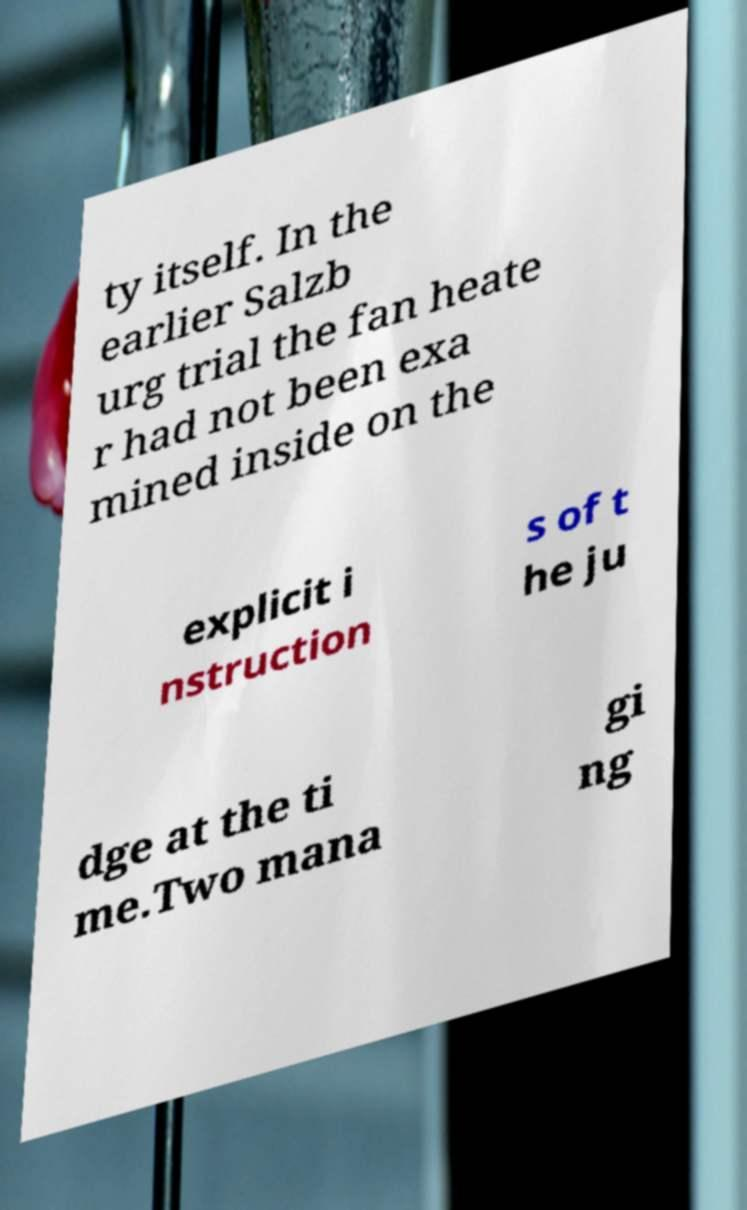I need the written content from this picture converted into text. Can you do that? ty itself. In the earlier Salzb urg trial the fan heate r had not been exa mined inside on the explicit i nstruction s of t he ju dge at the ti me.Two mana gi ng 